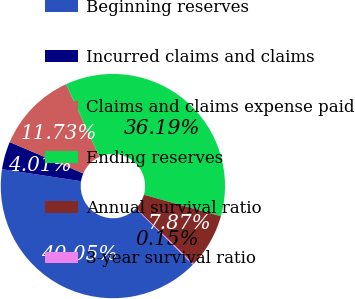Convert chart. <chart><loc_0><loc_0><loc_500><loc_500><pie_chart><fcel>Beginning reserves<fcel>Incurred claims and claims<fcel>Claims and claims expense paid<fcel>Ending reserves<fcel>Annual survival ratio<fcel>3-year survival ratio<nl><fcel>40.05%<fcel>4.01%<fcel>11.73%<fcel>36.19%<fcel>7.87%<fcel>0.15%<nl></chart> 